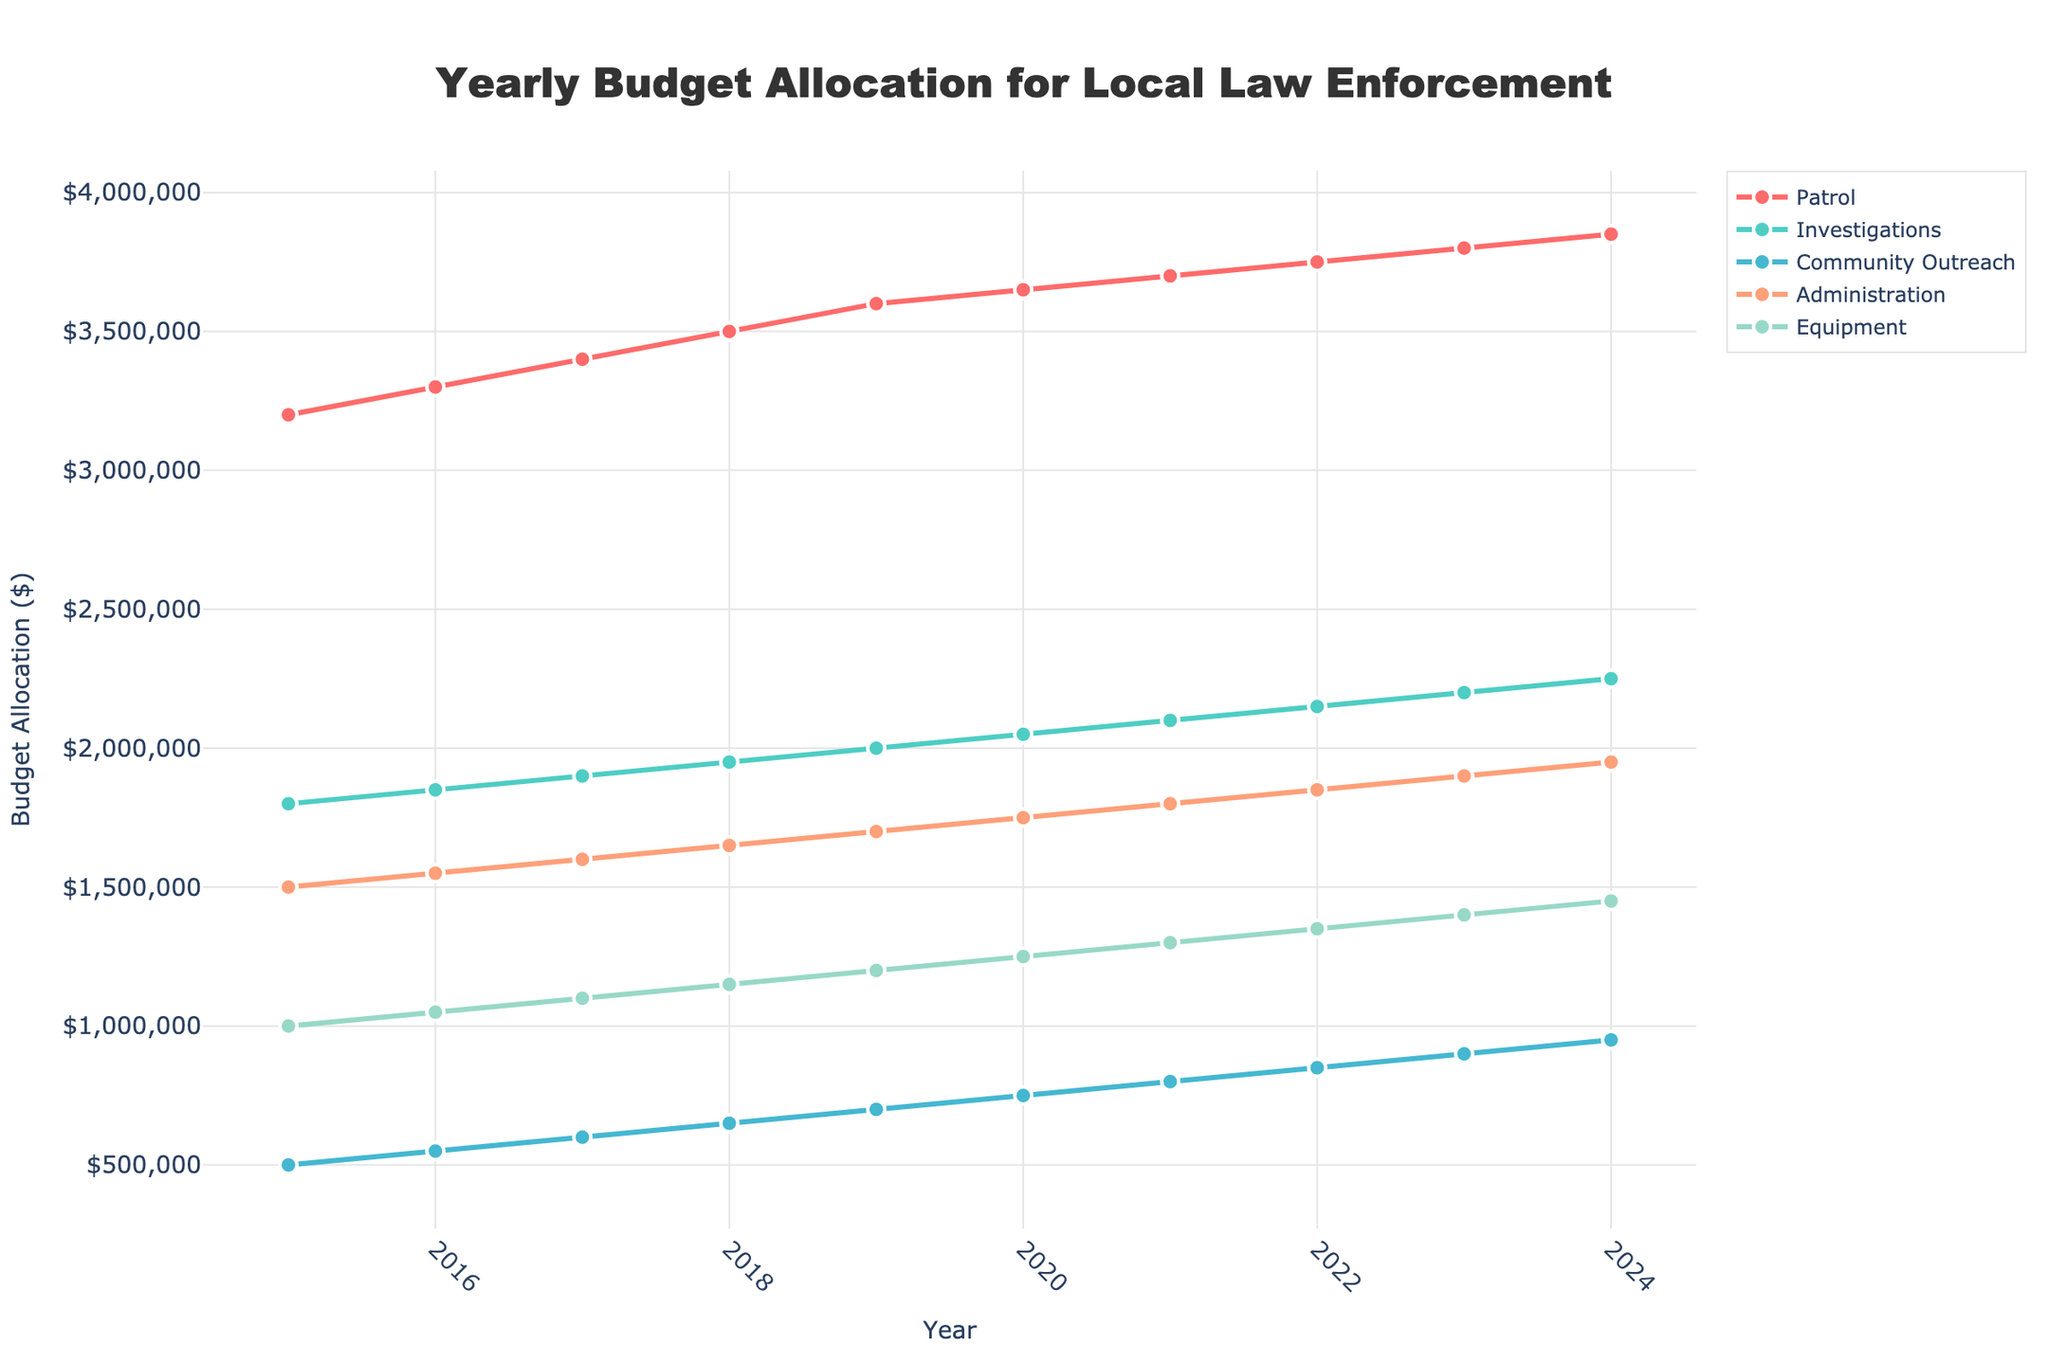What year had the greatest budget allocation for Patrol? By examining the line for the Patrol department, which is denoted by the color red, we can trace its highest point. According to the plot, the Patrol budget is highest in 2024.
Answer: 2024 Which department saw the most consistent increase in budget allocation over the years? Analyzing the slopes of all the lines for their smoothness and consistency without any dips reveals that the Patrol department's line (red) steadily increases every year.
Answer: Patrol What is the combined budget allocation for Investigations and Equipment in 2020? Check the y-values for Investigations (green line) and Equipment (blue line) for the year 2020. The values are $2,050,000 and $1,250,000, respectively. Summing these values gives $2,050,000 + $1,250,000.
Answer: $3,300,000 How does the budget allocation for Community Outreach in 2019 compare to Administration in 2021? Locate the respective points on the lines for Community Outreach (cyan) in 2019 and Administration (orange) in 2021. Community Outreach in 2019 shows $700,000, whereas Administration in 2021 is $1,800,000.
Answer: Administration in 2021 has a higher budget allocation What was the trend in budget allocation for the Equipment department from 2015 to 2024? Trace the blue line representing the Equipment department from start to end. The line shows a consistent upward trend each year.
Answer: Consistent increase What is the average budget allocation for the Patrol department over the years shown? Sum up the y-values for the Patrol department from 2015 to 2024: $3,200,000 + $3,300,000 + $3,400,000 + $3,500,000 + $3,600,000 + $3,650,000 + $3,700,000 + $3,750,000 + $3,800,000 + $3,850,000 and divide by 10.
Answer: $3,575,000 Which year had the largest total budget allocation across all departments? Add up the y-values of all departments for each year. The highest sum determines the year with the largest total budget allocation. 2024 results in the highest, with $3,850,000 + $2,250,000 + $950,000 + $1,950,000 + $1,450,000.
Answer: 2024 Did the budget for Community Outreach ever exceed $900,000? Examine the cyan line for Community Outreach and check for any point surpassing the $900,000 mark. The value in 2023 crosses this threshold with a $900,000 allocation.
Answer: Yes How much more was allocated to Investigation compared to Administration in 2022? Check the y-values for Investigations and Administration in 2022: $2,150,000 and $1,850,000, respectively. The difference is $2,150,000 - $1,850,000.
Answer: $300,000 Was there ever a year when the Administration budget saw no increase from the previous year? Look for any flat segments in the orange line representing Administration. No such segment exists, indicating regular annual increases.
Answer: No 